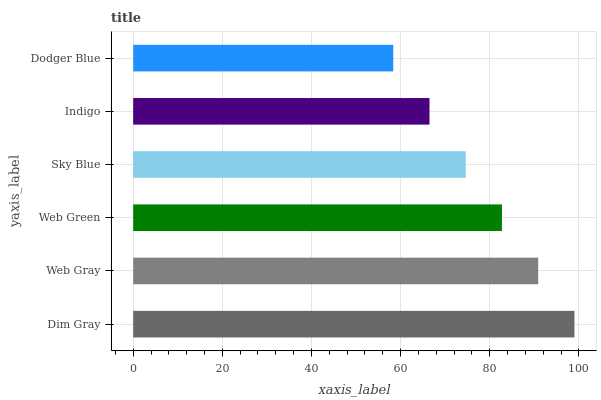Is Dodger Blue the minimum?
Answer yes or no. Yes. Is Dim Gray the maximum?
Answer yes or no. Yes. Is Web Gray the minimum?
Answer yes or no. No. Is Web Gray the maximum?
Answer yes or no. No. Is Dim Gray greater than Web Gray?
Answer yes or no. Yes. Is Web Gray less than Dim Gray?
Answer yes or no. Yes. Is Web Gray greater than Dim Gray?
Answer yes or no. No. Is Dim Gray less than Web Gray?
Answer yes or no. No. Is Web Green the high median?
Answer yes or no. Yes. Is Sky Blue the low median?
Answer yes or no. Yes. Is Web Gray the high median?
Answer yes or no. No. Is Indigo the low median?
Answer yes or no. No. 